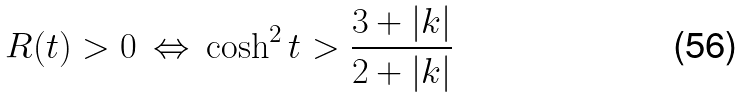Convert formula to latex. <formula><loc_0><loc_0><loc_500><loc_500>R ( t ) > 0 \, \Leftrightarrow \, \cosh ^ { 2 } t > \frac { 3 + | k | } { 2 + | k | }</formula> 